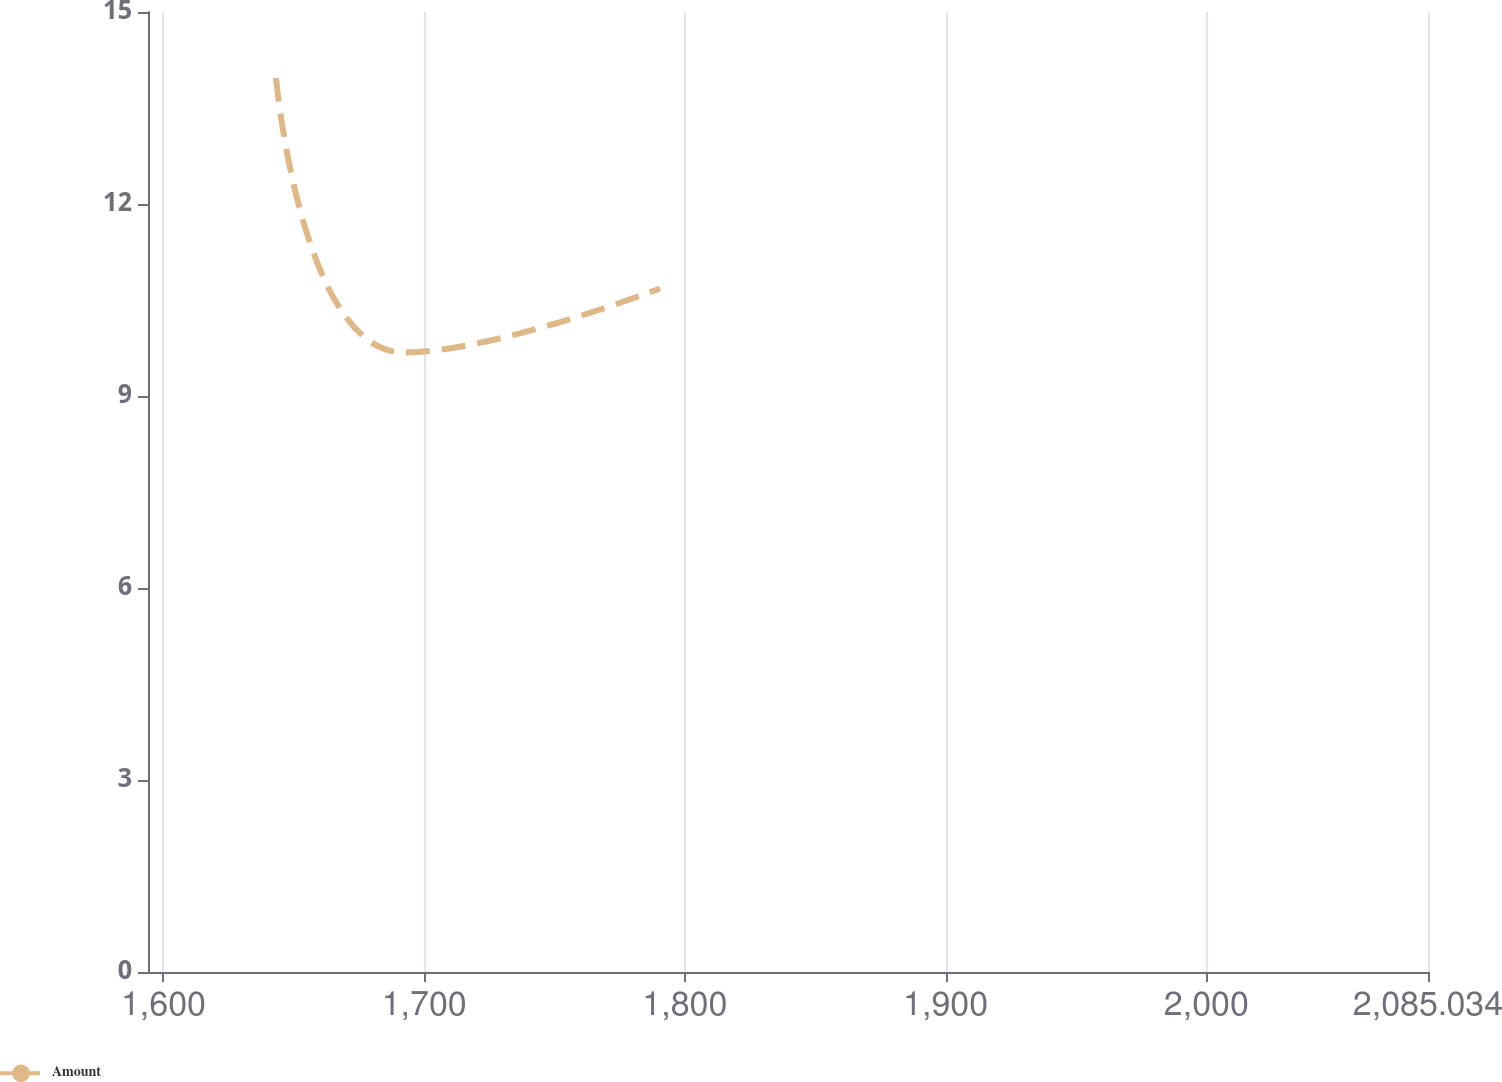<chart> <loc_0><loc_0><loc_500><loc_500><line_chart><ecel><fcel>Amount<nl><fcel>1643.17<fcel>13.97<nl><fcel>1692.25<fcel>9.68<nl><fcel>1790.44<fcel>10.68<nl><fcel>2085.27<fcel>4.95<nl><fcel>2134.13<fcel>3.95<nl></chart> 